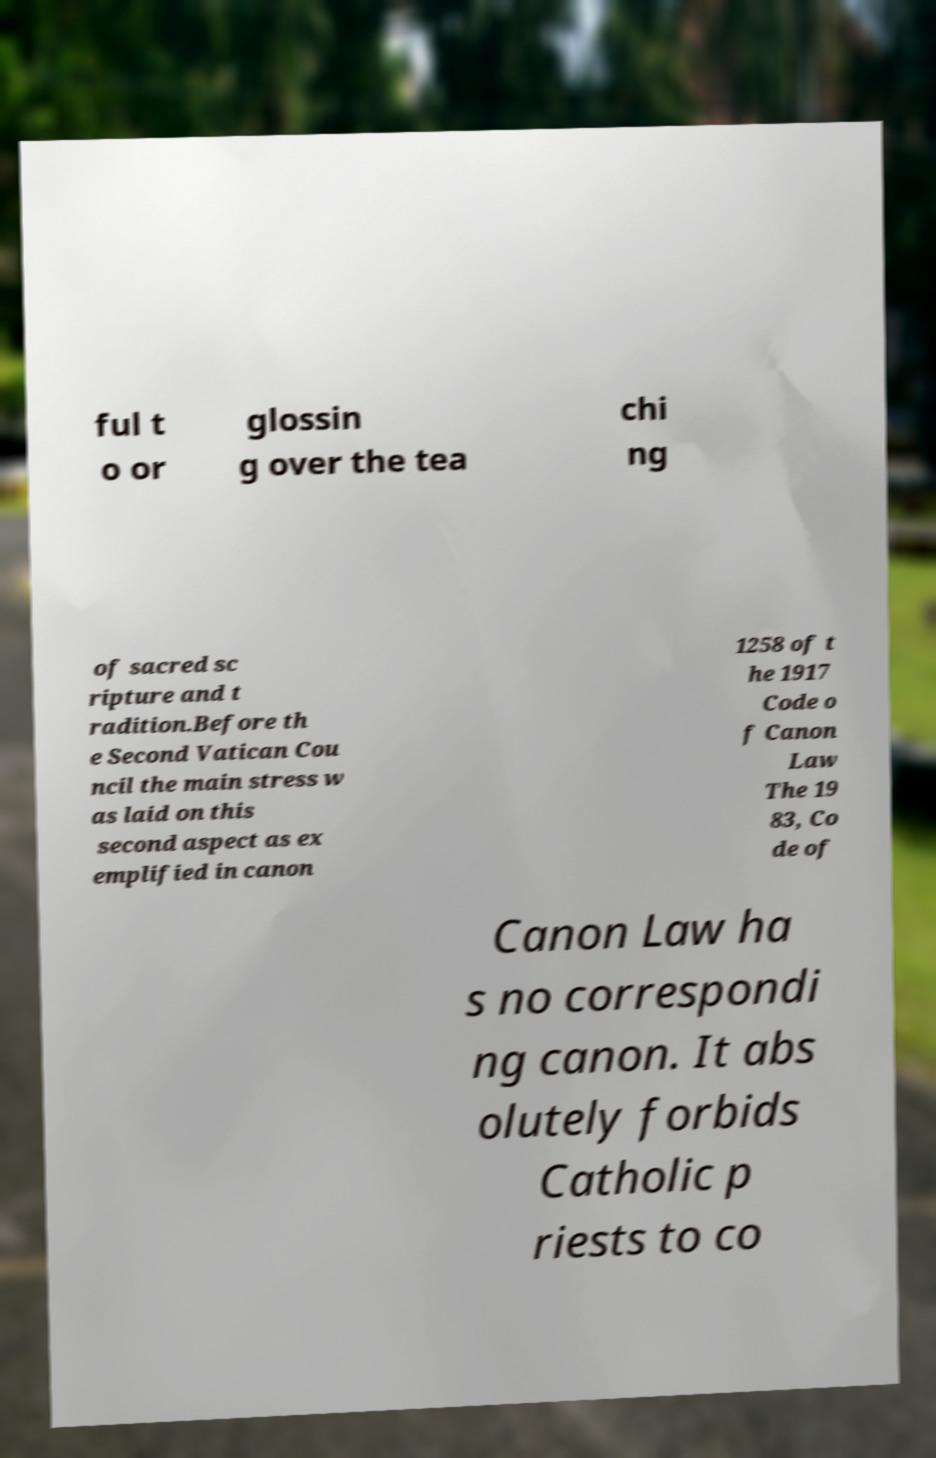Can you read and provide the text displayed in the image?This photo seems to have some interesting text. Can you extract and type it out for me? ful t o or glossin g over the tea chi ng of sacred sc ripture and t radition.Before th e Second Vatican Cou ncil the main stress w as laid on this second aspect as ex emplified in canon 1258 of t he 1917 Code o f Canon Law The 19 83, Co de of Canon Law ha s no correspondi ng canon. It abs olutely forbids Catholic p riests to co 